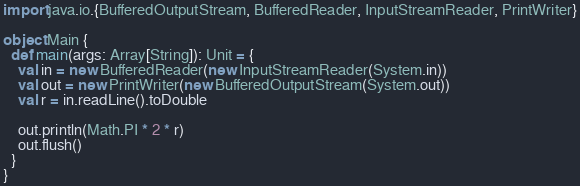Convert code to text. <code><loc_0><loc_0><loc_500><loc_500><_Scala_>import java.io.{BufferedOutputStream, BufferedReader, InputStreamReader, PrintWriter}

object Main {
  def main(args: Array[String]): Unit = {
    val in = new BufferedReader(new InputStreamReader(System.in))
    val out = new PrintWriter(new BufferedOutputStream(System.out))
    val r = in.readLine().toDouble

    out.println(Math.PI * 2 * r)
    out.flush()
  }
}
</code> 